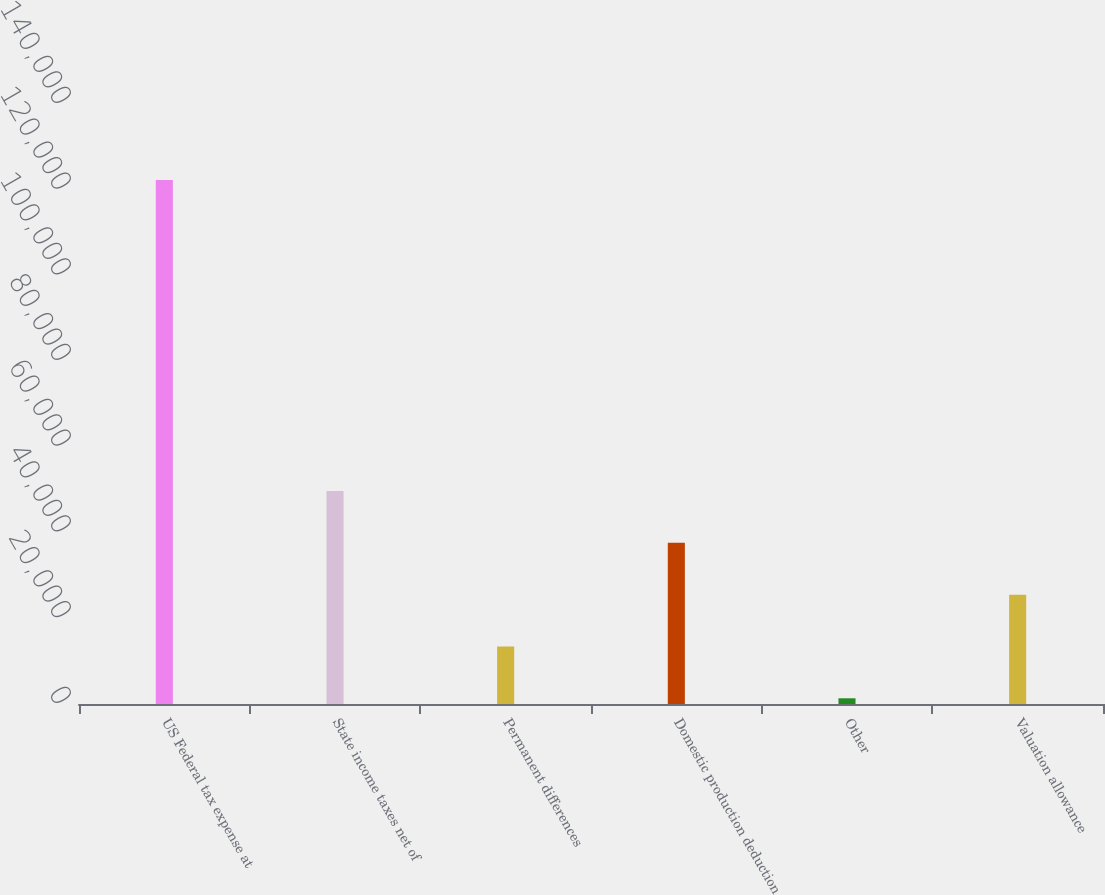Convert chart to OTSL. <chart><loc_0><loc_0><loc_500><loc_500><bar_chart><fcel>US Federal tax expense at<fcel>State income taxes net of<fcel>Permanent differences<fcel>Domestic production deduction<fcel>Other<fcel>Valuation allowance<nl><fcel>122256<fcel>49700.4<fcel>13422.6<fcel>37607.8<fcel>1330<fcel>25515.2<nl></chart> 